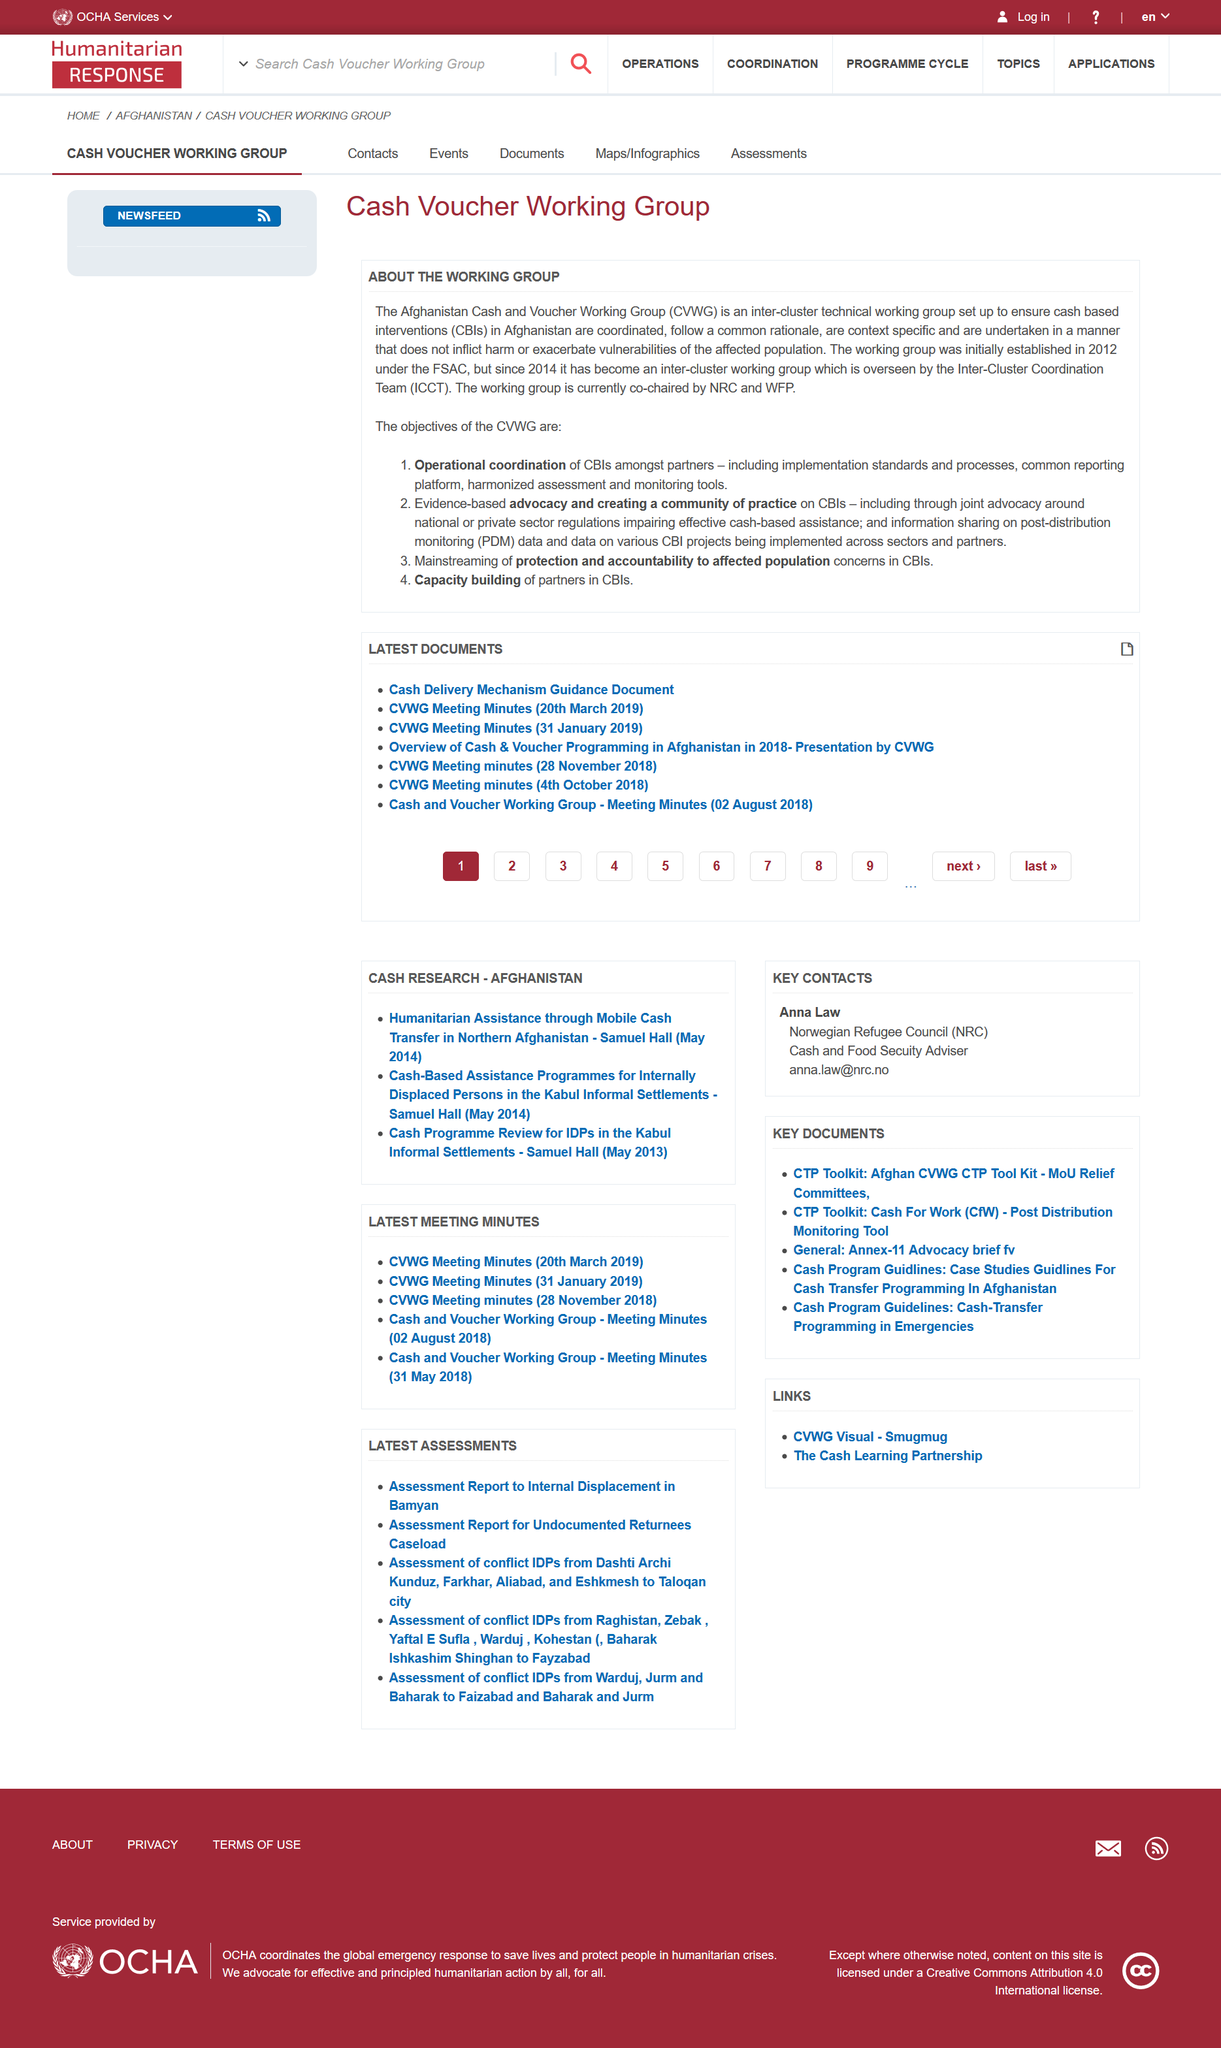Specify some key components in this picture. CBIs stands for cash based interventions, an economic concept referring to the use of cash incentives to encourage desired behaviors or outcomes. The Capacity Building of Partners in Climate-Resilient Value Chains (CBIs) is a key objective of the Climate-Resilient Value Chain Working Group (CVWG). The acronym ICCT stands for Inter-Cluster Coordination Team, which is a group of individuals responsible for coordinating efforts among different clusters. 